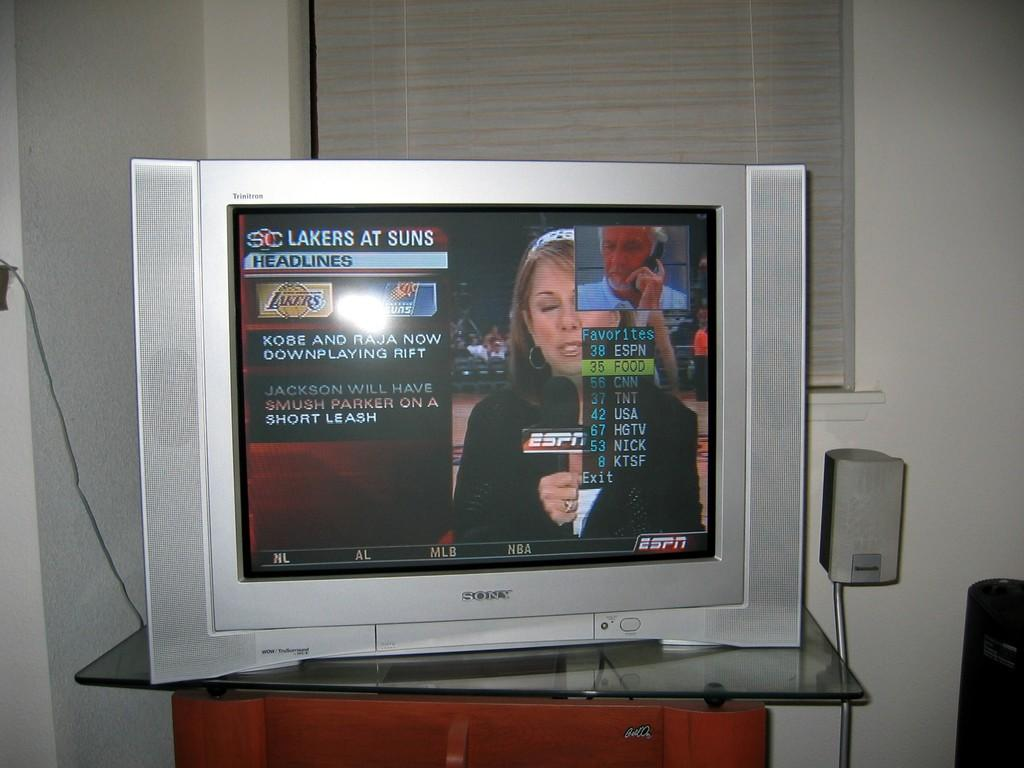<image>
Provide a brief description of the given image. A Sony television displaying the Lakers At Suns Headlines. 